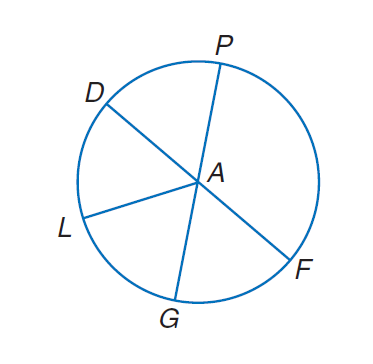Answer the mathemtical geometry problem and directly provide the correct option letter.
Question: Circle A has diameters D F and P G. If P A = 7, find P G.
Choices: A: 7 B: 14 C: 28 D: 35 B 